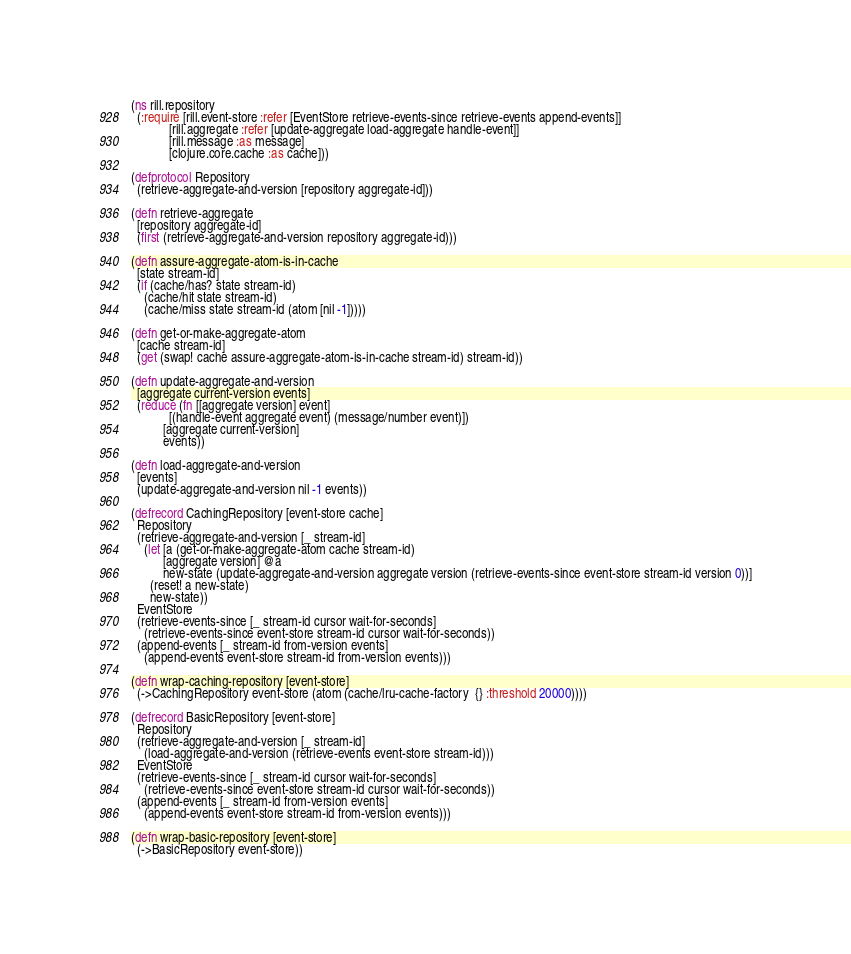Convert code to text. <code><loc_0><loc_0><loc_500><loc_500><_Clojure_>(ns rill.repository
  (:require [rill.event-store :refer [EventStore retrieve-events-since retrieve-events append-events]]
            [rill.aggregate :refer [update-aggregate load-aggregate handle-event]]
            [rill.message :as message]
            [clojure.core.cache :as cache]))

(defprotocol Repository
  (retrieve-aggregate-and-version [repository aggregate-id]))

(defn retrieve-aggregate
  [repository aggregate-id]
  (first (retrieve-aggregate-and-version repository aggregate-id)))

(defn assure-aggregate-atom-is-in-cache
  [state stream-id]
  (if (cache/has? state stream-id)
    (cache/hit state stream-id)
    (cache/miss state stream-id (atom [nil -1]))))

(defn get-or-make-aggregate-atom
  [cache stream-id]
  (get (swap! cache assure-aggregate-atom-is-in-cache stream-id) stream-id))

(defn update-aggregate-and-version
  [aggregate current-version events]
  (reduce (fn [[aggregate version] event]
            [(handle-event aggregate event) (message/number event)])
          [aggregate current-version]
          events))

(defn load-aggregate-and-version
  [events]
  (update-aggregate-and-version nil -1 events))

(defrecord CachingRepository [event-store cache]
  Repository
  (retrieve-aggregate-and-version [_ stream-id]
    (let [a (get-or-make-aggregate-atom cache stream-id)
          [aggregate version] @a
          new-state (update-aggregate-and-version aggregate version (retrieve-events-since event-store stream-id version 0))]
      (reset! a new-state)
      new-state))
  EventStore
  (retrieve-events-since [_ stream-id cursor wait-for-seconds]
    (retrieve-events-since event-store stream-id cursor wait-for-seconds))
  (append-events [_ stream-id from-version events]
    (append-events event-store stream-id from-version events)))

(defn wrap-caching-repository [event-store]
  (->CachingRepository event-store (atom (cache/lru-cache-factory  {} :threshold 20000))))

(defrecord BasicRepository [event-store]
  Repository
  (retrieve-aggregate-and-version [_ stream-id]
    (load-aggregate-and-version (retrieve-events event-store stream-id)))
  EventStore
  (retrieve-events-since [_ stream-id cursor wait-for-seconds]
    (retrieve-events-since event-store stream-id cursor wait-for-seconds))
  (append-events [_ stream-id from-version events]
    (append-events event-store stream-id from-version events)))

(defn wrap-basic-repository [event-store]
  (->BasicRepository event-store))

</code> 